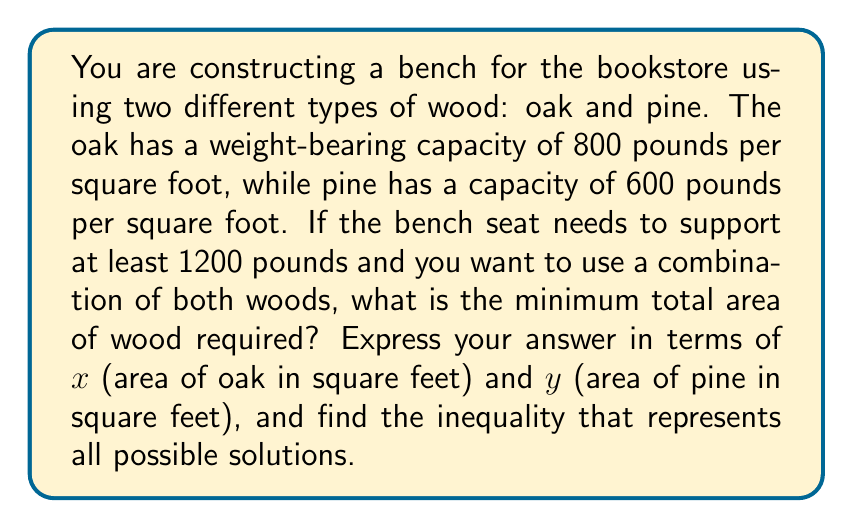Solve this math problem. Let's approach this step-by-step:

1) Let $x$ be the area of oak in square feet and $y$ be the area of pine in square feet.

2) The weight-bearing capacity of oak is 800 lbs/sq ft, so the total weight oak can support is $800x$.

3) The weight-bearing capacity of pine is 600 lbs/sq ft, so the total weight pine can support is $600y$.

4) The total weight the bench needs to support is at least 1200 lbs.

5) We can express this as an inequality:

   $800x + 600y \geq 1200$

6) To simplify, divide both sides by 200:

   $4x + 3y \geq 6$

7) The total area of wood used is $x + y$.

8) We want to minimize $x + y$ subject to the constraint $4x + 3y \geq 6$ and $x, y \geq 0$.

Therefore, the inequality representing all possible solutions is:

$$4x + 3y \geq 6, \quad x \geq 0, \quad y \geq 0$$

This inequality, along with the objective to minimize $x + y$, fully describes the problem.
Answer: $4x + 3y \geq 6, x \geq 0, y \geq 0$ 